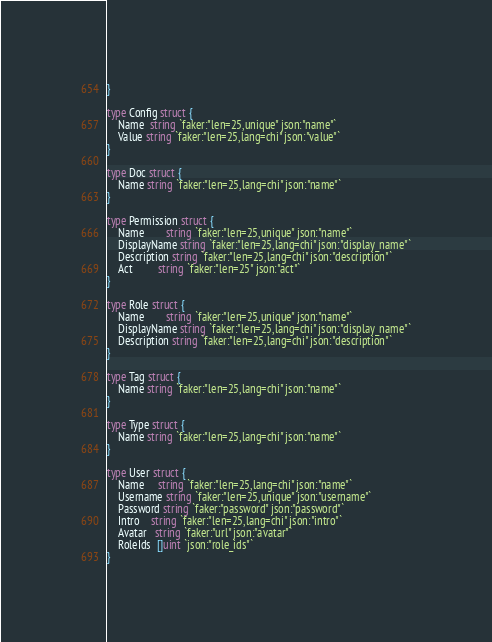Convert code to text. <code><loc_0><loc_0><loc_500><loc_500><_Go_>}

type Config struct {
	Name  string `faker:"len=25,unique" json:"name"`
	Value string `faker:"len=25,lang=chi" json:"value"`
}

type Doc struct {
	Name string `faker:"len=25,lang=chi" json:"name"`
}

type Permission struct {
	Name        string `faker:"len=25,unique" json:"name"`
	DisplayName string `faker:"len=25,lang=chi" json:"display_name"`
	Description string `faker:"len=25,lang=chi" json:"description"`
	Act         string `faker:"len=25" json:"act"`
}

type Role struct {
	Name        string `faker:"len=25,unique" json:"name"`
	DisplayName string `faker:"len=25,lang=chi" json:"display_name"`
	Description string `faker:"len=25,lang=chi" json:"description"`
}

type Tag struct {
	Name string `faker:"len=25,lang=chi" json:"name"`
}

type Type struct {
	Name string `faker:"len=25,lang=chi" json:"name"`
}

type User struct {
	Name     string `faker:"len=25,lang=chi" json:"name"`
	Username string `faker:"len=25,unique" json:"username"`
	Password string `faker:"password" json:"password"`
	Intro    string `faker:"len=25,lang=chi" json:"intro"`
	Avatar   string `faker:"url" json:"avatar"`
	RoleIds  []uint `json:"role_ids"`
}
</code> 